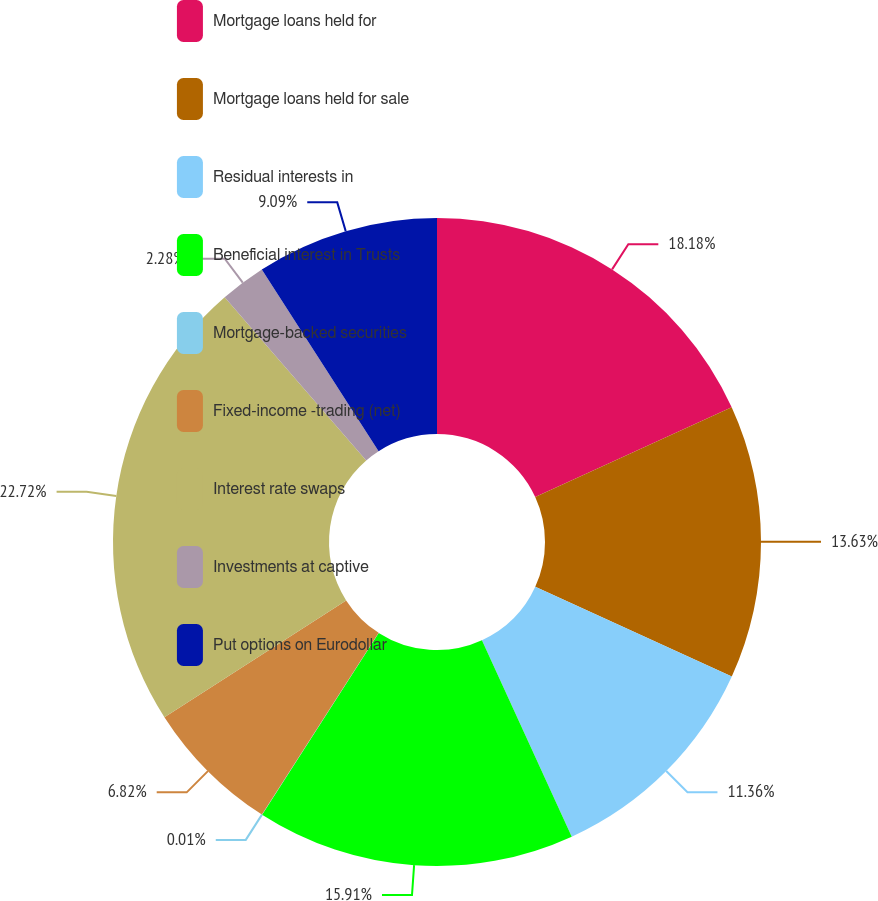Convert chart. <chart><loc_0><loc_0><loc_500><loc_500><pie_chart><fcel>Mortgage loans held for<fcel>Mortgage loans held for sale<fcel>Residual interests in<fcel>Beneficial interest in Trusts<fcel>Mortgage-backed securities<fcel>Fixed-income -trading (net)<fcel>Interest rate swaps<fcel>Investments at captive<fcel>Put options on Eurodollar<nl><fcel>18.17%<fcel>13.63%<fcel>11.36%<fcel>15.9%<fcel>0.01%<fcel>6.82%<fcel>22.71%<fcel>2.28%<fcel>9.09%<nl></chart> 